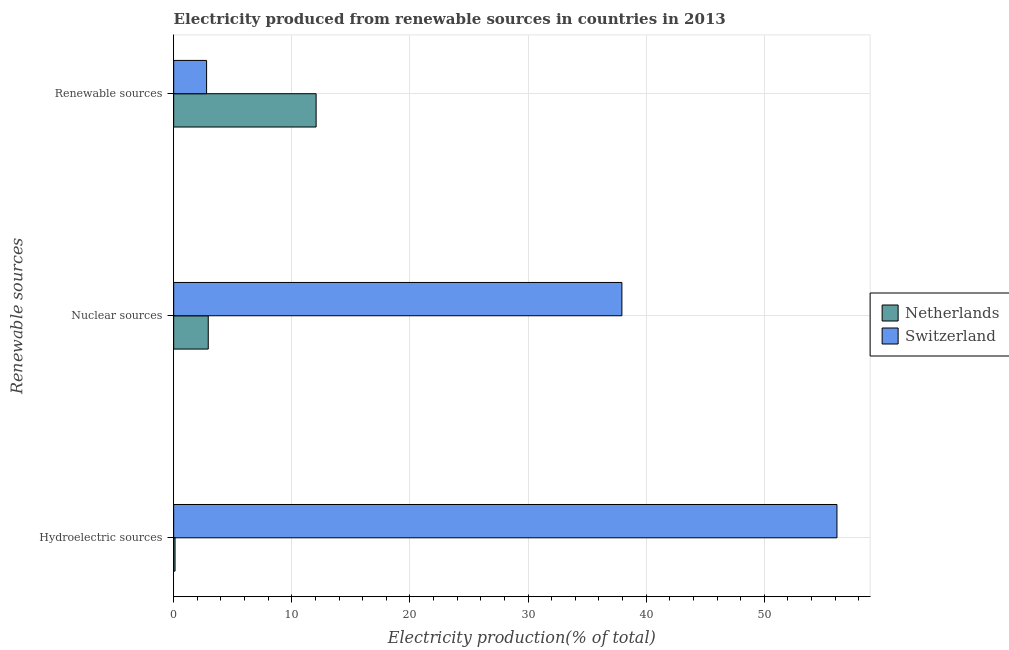How many different coloured bars are there?
Provide a succinct answer. 2. How many groups of bars are there?
Make the answer very short. 3. How many bars are there on the 3rd tick from the bottom?
Keep it short and to the point. 2. What is the label of the 3rd group of bars from the top?
Offer a very short reply. Hydroelectric sources. What is the percentage of electricity produced by nuclear sources in Netherlands?
Give a very brief answer. 2.93. Across all countries, what is the maximum percentage of electricity produced by nuclear sources?
Keep it short and to the point. 37.95. Across all countries, what is the minimum percentage of electricity produced by nuclear sources?
Keep it short and to the point. 2.93. In which country was the percentage of electricity produced by hydroelectric sources maximum?
Give a very brief answer. Switzerland. In which country was the percentage of electricity produced by renewable sources minimum?
Offer a very short reply. Switzerland. What is the total percentage of electricity produced by renewable sources in the graph?
Give a very brief answer. 14.85. What is the difference between the percentage of electricity produced by hydroelectric sources in Switzerland and that in Netherlands?
Offer a terse response. 56.04. What is the difference between the percentage of electricity produced by hydroelectric sources in Netherlands and the percentage of electricity produced by nuclear sources in Switzerland?
Offer a terse response. -37.83. What is the average percentage of electricity produced by hydroelectric sources per country?
Give a very brief answer. 28.13. What is the difference between the percentage of electricity produced by nuclear sources and percentage of electricity produced by renewable sources in Switzerland?
Provide a short and direct response. 35.16. What is the ratio of the percentage of electricity produced by hydroelectric sources in Netherlands to that in Switzerland?
Your answer should be compact. 0. Is the percentage of electricity produced by nuclear sources in Netherlands less than that in Switzerland?
Provide a short and direct response. Yes. What is the difference between the highest and the second highest percentage of electricity produced by hydroelectric sources?
Your response must be concise. 56.04. What is the difference between the highest and the lowest percentage of electricity produced by renewable sources?
Your response must be concise. 9.27. In how many countries, is the percentage of electricity produced by hydroelectric sources greater than the average percentage of electricity produced by hydroelectric sources taken over all countries?
Keep it short and to the point. 1. Is the sum of the percentage of electricity produced by hydroelectric sources in Netherlands and Switzerland greater than the maximum percentage of electricity produced by renewable sources across all countries?
Give a very brief answer. Yes. What does the 1st bar from the bottom in Hydroelectric sources represents?
Provide a short and direct response. Netherlands. Are all the bars in the graph horizontal?
Ensure brevity in your answer.  Yes. How many countries are there in the graph?
Give a very brief answer. 2. What is the difference between two consecutive major ticks on the X-axis?
Ensure brevity in your answer.  10. How many legend labels are there?
Provide a short and direct response. 2. What is the title of the graph?
Ensure brevity in your answer.  Electricity produced from renewable sources in countries in 2013. Does "Spain" appear as one of the legend labels in the graph?
Give a very brief answer. No. What is the label or title of the Y-axis?
Make the answer very short. Renewable sources. What is the Electricity production(% of total) of Netherlands in Hydroelectric sources?
Keep it short and to the point. 0.12. What is the Electricity production(% of total) in Switzerland in Hydroelectric sources?
Your answer should be very brief. 56.15. What is the Electricity production(% of total) of Netherlands in Nuclear sources?
Keep it short and to the point. 2.93. What is the Electricity production(% of total) in Switzerland in Nuclear sources?
Your response must be concise. 37.95. What is the Electricity production(% of total) in Netherlands in Renewable sources?
Your answer should be very brief. 12.06. What is the Electricity production(% of total) of Switzerland in Renewable sources?
Make the answer very short. 2.79. Across all Renewable sources, what is the maximum Electricity production(% of total) of Netherlands?
Keep it short and to the point. 12.06. Across all Renewable sources, what is the maximum Electricity production(% of total) of Switzerland?
Provide a succinct answer. 56.15. Across all Renewable sources, what is the minimum Electricity production(% of total) of Netherlands?
Ensure brevity in your answer.  0.12. Across all Renewable sources, what is the minimum Electricity production(% of total) in Switzerland?
Provide a short and direct response. 2.79. What is the total Electricity production(% of total) of Netherlands in the graph?
Your answer should be very brief. 15.1. What is the total Electricity production(% of total) of Switzerland in the graph?
Provide a succinct answer. 96.89. What is the difference between the Electricity production(% of total) of Netherlands in Hydroelectric sources and that in Nuclear sources?
Provide a succinct answer. -2.81. What is the difference between the Electricity production(% of total) of Switzerland in Hydroelectric sources and that in Nuclear sources?
Ensure brevity in your answer.  18.21. What is the difference between the Electricity production(% of total) of Netherlands in Hydroelectric sources and that in Renewable sources?
Your answer should be very brief. -11.94. What is the difference between the Electricity production(% of total) in Switzerland in Hydroelectric sources and that in Renewable sources?
Offer a terse response. 53.37. What is the difference between the Electricity production(% of total) in Netherlands in Nuclear sources and that in Renewable sources?
Keep it short and to the point. -9.13. What is the difference between the Electricity production(% of total) in Switzerland in Nuclear sources and that in Renewable sources?
Your response must be concise. 35.16. What is the difference between the Electricity production(% of total) in Netherlands in Hydroelectric sources and the Electricity production(% of total) in Switzerland in Nuclear sources?
Your answer should be compact. -37.83. What is the difference between the Electricity production(% of total) of Netherlands in Hydroelectric sources and the Electricity production(% of total) of Switzerland in Renewable sources?
Provide a succinct answer. -2.67. What is the difference between the Electricity production(% of total) in Netherlands in Nuclear sources and the Electricity production(% of total) in Switzerland in Renewable sources?
Give a very brief answer. 0.14. What is the average Electricity production(% of total) of Netherlands per Renewable sources?
Offer a very short reply. 5.03. What is the average Electricity production(% of total) of Switzerland per Renewable sources?
Give a very brief answer. 32.3. What is the difference between the Electricity production(% of total) in Netherlands and Electricity production(% of total) in Switzerland in Hydroelectric sources?
Your response must be concise. -56.04. What is the difference between the Electricity production(% of total) of Netherlands and Electricity production(% of total) of Switzerland in Nuclear sources?
Give a very brief answer. -35.02. What is the difference between the Electricity production(% of total) in Netherlands and Electricity production(% of total) in Switzerland in Renewable sources?
Offer a terse response. 9.27. What is the ratio of the Electricity production(% of total) in Netherlands in Hydroelectric sources to that in Nuclear sources?
Offer a very short reply. 0.04. What is the ratio of the Electricity production(% of total) in Switzerland in Hydroelectric sources to that in Nuclear sources?
Ensure brevity in your answer.  1.48. What is the ratio of the Electricity production(% of total) of Netherlands in Hydroelectric sources to that in Renewable sources?
Provide a succinct answer. 0.01. What is the ratio of the Electricity production(% of total) of Switzerland in Hydroelectric sources to that in Renewable sources?
Give a very brief answer. 20.15. What is the ratio of the Electricity production(% of total) in Netherlands in Nuclear sources to that in Renewable sources?
Your answer should be compact. 0.24. What is the ratio of the Electricity production(% of total) in Switzerland in Nuclear sources to that in Renewable sources?
Your response must be concise. 13.61. What is the difference between the highest and the second highest Electricity production(% of total) in Netherlands?
Your answer should be very brief. 9.13. What is the difference between the highest and the second highest Electricity production(% of total) of Switzerland?
Your answer should be compact. 18.21. What is the difference between the highest and the lowest Electricity production(% of total) of Netherlands?
Make the answer very short. 11.94. What is the difference between the highest and the lowest Electricity production(% of total) of Switzerland?
Make the answer very short. 53.37. 